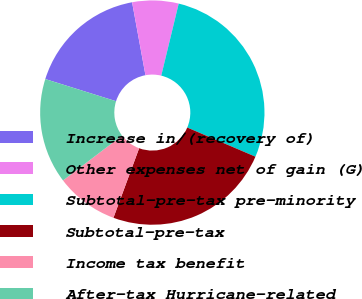Convert chart. <chart><loc_0><loc_0><loc_500><loc_500><pie_chart><fcel>Increase in/(recovery of)<fcel>Other expenses net of gain (G)<fcel>Subtotal-pre-tax pre-minority<fcel>Subtotal-pre-tax<fcel>Income tax benefit<fcel>After-tax Hurricane-related<nl><fcel>17.28%<fcel>6.67%<fcel>27.65%<fcel>24.2%<fcel>9.02%<fcel>15.18%<nl></chart> 